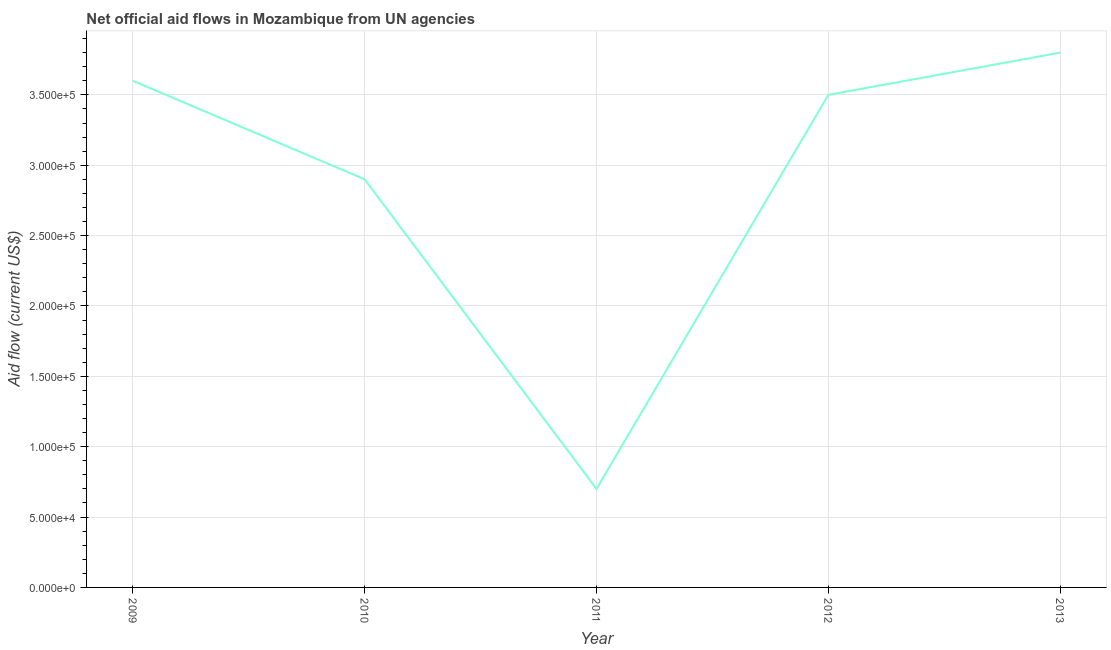What is the net official flows from un agencies in 2012?
Provide a succinct answer. 3.50e+05. Across all years, what is the maximum net official flows from un agencies?
Make the answer very short. 3.80e+05. Across all years, what is the minimum net official flows from un agencies?
Make the answer very short. 7.00e+04. What is the sum of the net official flows from un agencies?
Your answer should be compact. 1.45e+06. What is the difference between the net official flows from un agencies in 2009 and 2011?
Offer a terse response. 2.90e+05. What is the average net official flows from un agencies per year?
Ensure brevity in your answer.  2.90e+05. What is the median net official flows from un agencies?
Provide a short and direct response. 3.50e+05. In how many years, is the net official flows from un agencies greater than 370000 US$?
Make the answer very short. 1. Do a majority of the years between 2013 and 2011 (inclusive) have net official flows from un agencies greater than 230000 US$?
Keep it short and to the point. No. What is the ratio of the net official flows from un agencies in 2011 to that in 2013?
Offer a very short reply. 0.18. Is the net official flows from un agencies in 2011 less than that in 2013?
Your answer should be compact. Yes. Is the sum of the net official flows from un agencies in 2011 and 2012 greater than the maximum net official flows from un agencies across all years?
Make the answer very short. Yes. What is the difference between the highest and the lowest net official flows from un agencies?
Keep it short and to the point. 3.10e+05. In how many years, is the net official flows from un agencies greater than the average net official flows from un agencies taken over all years?
Your answer should be very brief. 3. What is the difference between two consecutive major ticks on the Y-axis?
Make the answer very short. 5.00e+04. Are the values on the major ticks of Y-axis written in scientific E-notation?
Give a very brief answer. Yes. Does the graph contain any zero values?
Give a very brief answer. No. What is the title of the graph?
Offer a very short reply. Net official aid flows in Mozambique from UN agencies. What is the label or title of the Y-axis?
Provide a short and direct response. Aid flow (current US$). What is the Aid flow (current US$) in 2010?
Ensure brevity in your answer.  2.90e+05. What is the Aid flow (current US$) of 2012?
Keep it short and to the point. 3.50e+05. What is the difference between the Aid flow (current US$) in 2009 and 2011?
Your answer should be compact. 2.90e+05. What is the difference between the Aid flow (current US$) in 2009 and 2012?
Ensure brevity in your answer.  10000. What is the difference between the Aid flow (current US$) in 2009 and 2013?
Offer a very short reply. -2.00e+04. What is the difference between the Aid flow (current US$) in 2010 and 2013?
Give a very brief answer. -9.00e+04. What is the difference between the Aid flow (current US$) in 2011 and 2012?
Keep it short and to the point. -2.80e+05. What is the difference between the Aid flow (current US$) in 2011 and 2013?
Ensure brevity in your answer.  -3.10e+05. What is the difference between the Aid flow (current US$) in 2012 and 2013?
Your answer should be compact. -3.00e+04. What is the ratio of the Aid flow (current US$) in 2009 to that in 2010?
Your answer should be compact. 1.24. What is the ratio of the Aid flow (current US$) in 2009 to that in 2011?
Your answer should be compact. 5.14. What is the ratio of the Aid flow (current US$) in 2009 to that in 2012?
Make the answer very short. 1.03. What is the ratio of the Aid flow (current US$) in 2009 to that in 2013?
Offer a terse response. 0.95. What is the ratio of the Aid flow (current US$) in 2010 to that in 2011?
Provide a short and direct response. 4.14. What is the ratio of the Aid flow (current US$) in 2010 to that in 2012?
Your answer should be very brief. 0.83. What is the ratio of the Aid flow (current US$) in 2010 to that in 2013?
Your answer should be compact. 0.76. What is the ratio of the Aid flow (current US$) in 2011 to that in 2013?
Make the answer very short. 0.18. What is the ratio of the Aid flow (current US$) in 2012 to that in 2013?
Keep it short and to the point. 0.92. 